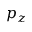<formula> <loc_0><loc_0><loc_500><loc_500>p _ { z }</formula> 